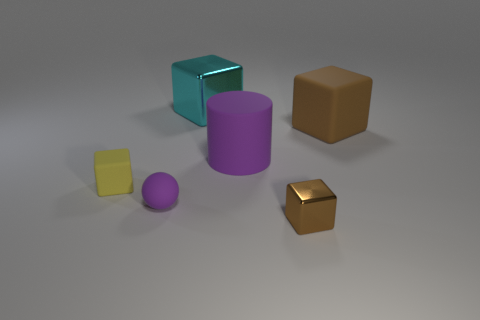Add 2 tiny purple blocks. How many objects exist? 8 Subtract 1 blocks. How many blocks are left? 3 Subtract all small brown cubes. How many cubes are left? 3 Subtract all cyan blocks. How many blocks are left? 3 Subtract all spheres. How many objects are left? 5 Subtract all small cyan rubber cylinders. Subtract all tiny brown shiny objects. How many objects are left? 5 Add 3 rubber balls. How many rubber balls are left? 4 Add 3 metal things. How many metal things exist? 5 Subtract 0 purple cubes. How many objects are left? 6 Subtract all green cubes. Subtract all blue spheres. How many cubes are left? 4 